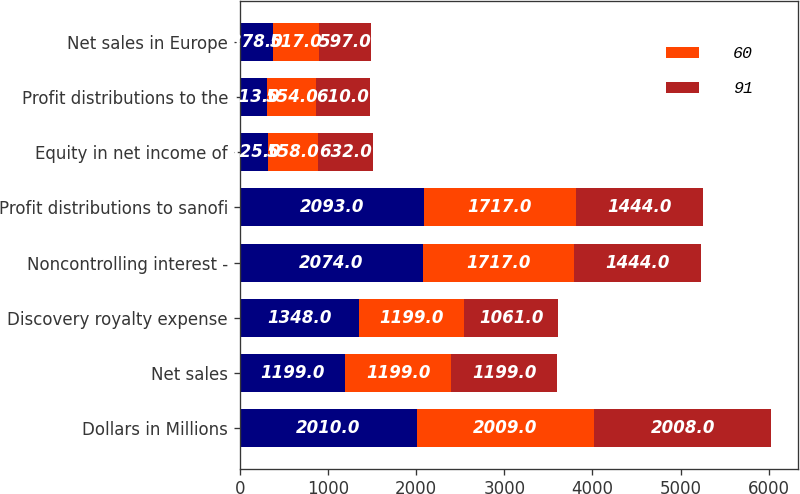<chart> <loc_0><loc_0><loc_500><loc_500><stacked_bar_chart><ecel><fcel>Dollars in Millions<fcel>Net sales<fcel>Discovery royalty expense<fcel>Noncontrolling interest -<fcel>Profit distributions to sanofi<fcel>Equity in net income of<fcel>Profit distributions to the<fcel>Net sales in Europe<nl><fcel>nan<fcel>2010<fcel>1199<fcel>1348<fcel>2074<fcel>2093<fcel>325<fcel>313<fcel>378<nl><fcel>60<fcel>2009<fcel>1199<fcel>1199<fcel>1717<fcel>1717<fcel>558<fcel>554<fcel>517<nl><fcel>91<fcel>2008<fcel>1199<fcel>1061<fcel>1444<fcel>1444<fcel>632<fcel>610<fcel>597<nl></chart> 